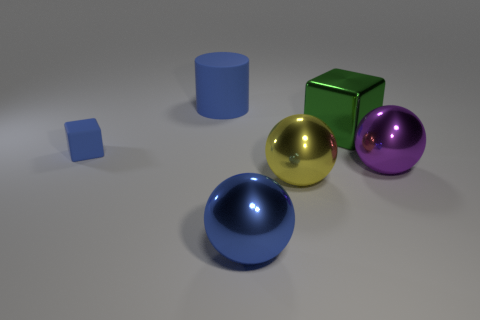Add 4 large purple shiny things. How many objects exist? 10 Subtract all cylinders. How many objects are left? 5 Add 6 red matte objects. How many red matte objects exist? 6 Subtract 0 brown spheres. How many objects are left? 6 Subtract all large rubber objects. Subtract all large purple objects. How many objects are left? 4 Add 5 metallic balls. How many metallic balls are left? 8 